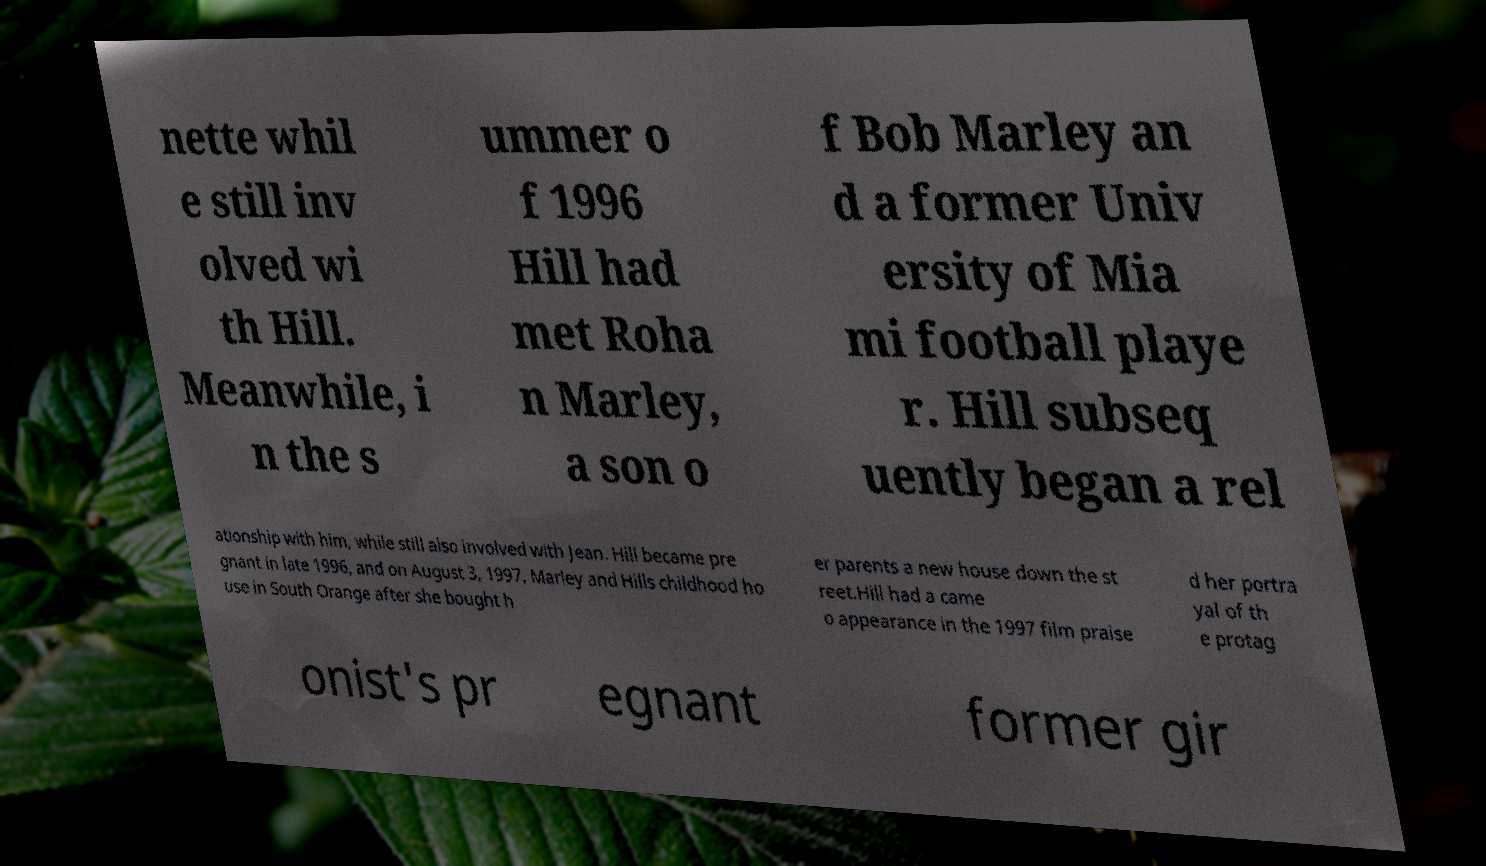There's text embedded in this image that I need extracted. Can you transcribe it verbatim? nette whil e still inv olved wi th Hill. Meanwhile, i n the s ummer o f 1996 Hill had met Roha n Marley, a son o f Bob Marley an d a former Univ ersity of Mia mi football playe r. Hill subseq uently began a rel ationship with him, while still also involved with Jean. Hill became pre gnant in late 1996, and on August 3, 1997, Marley and Hills childhood ho use in South Orange after she bought h er parents a new house down the st reet.Hill had a came o appearance in the 1997 film praise d her portra yal of th e protag onist's pr egnant former gir 